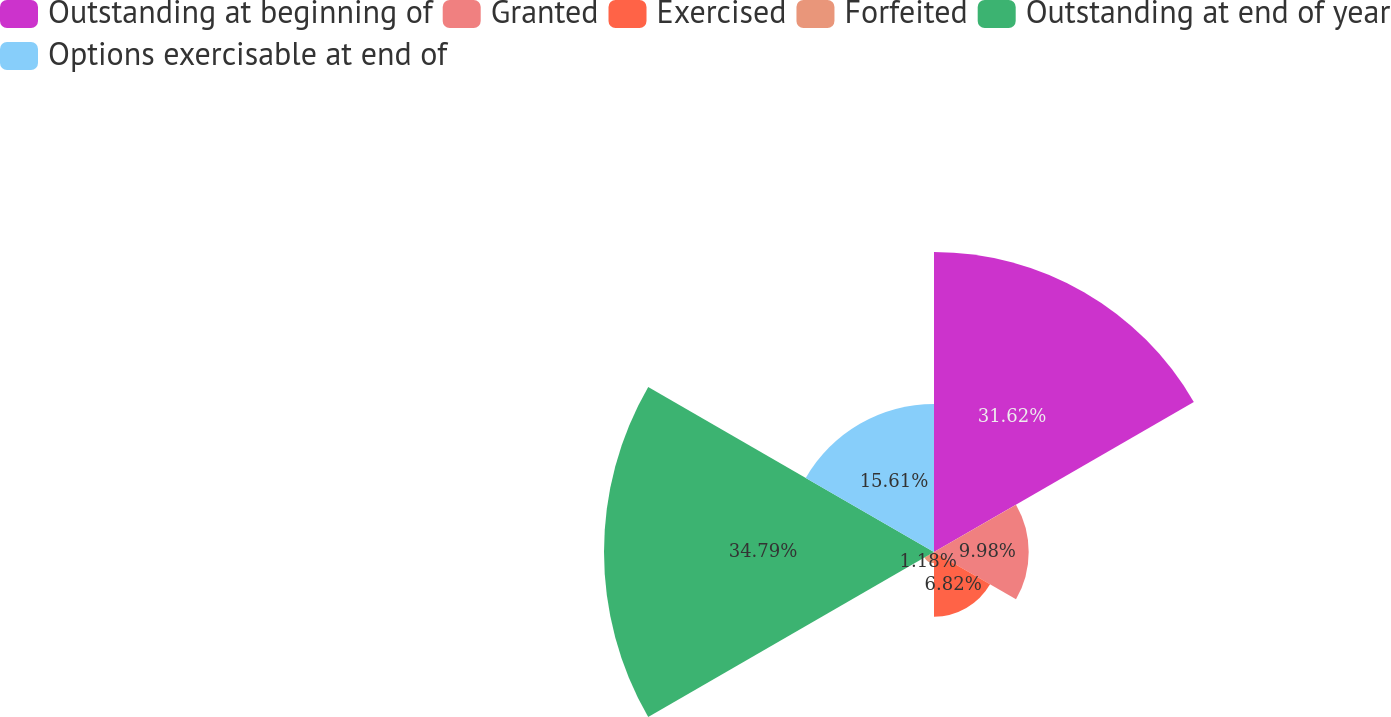Convert chart to OTSL. <chart><loc_0><loc_0><loc_500><loc_500><pie_chart><fcel>Outstanding at beginning of<fcel>Granted<fcel>Exercised<fcel>Forfeited<fcel>Outstanding at end of year<fcel>Options exercisable at end of<nl><fcel>31.62%<fcel>9.98%<fcel>6.82%<fcel>1.18%<fcel>34.78%<fcel>15.61%<nl></chart> 